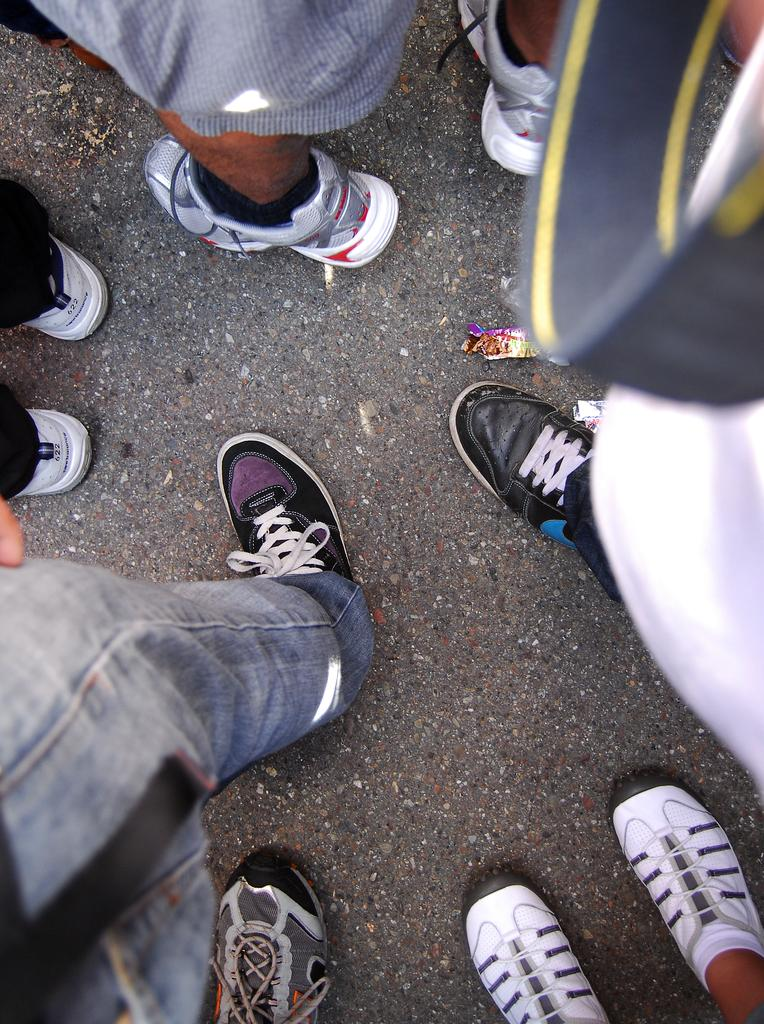What body parts are visible in the image? There are persons' legs visible in the image. What are the legs wearing? The legs are wearing shoes. Where are the legs located? The legs are on the road. Are the persons' heads visible in the image? No, only the legs are visible in the image, so the heads are not visible. 